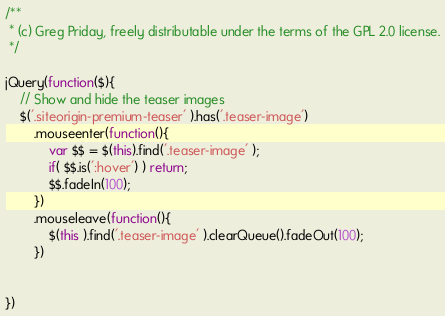<code> <loc_0><loc_0><loc_500><loc_500><_JavaScript_>/**
 * (c) Greg Priday, freely distributable under the terms of the GPL 2.0 license.
 */

jQuery(function($){
    // Show and hide the teaser images
    $('.siteorigin-premium-teaser' ).has('.teaser-image')
        .mouseenter(function(){
            var $$ = $(this).find('.teaser-image' );
            if( $$.is(':hover') ) return;
            $$.fadeIn(100);
        })
        .mouseleave(function(){
            $(this ).find('.teaser-image' ).clearQueue().fadeOut(100);
        })
        
    
})</code> 